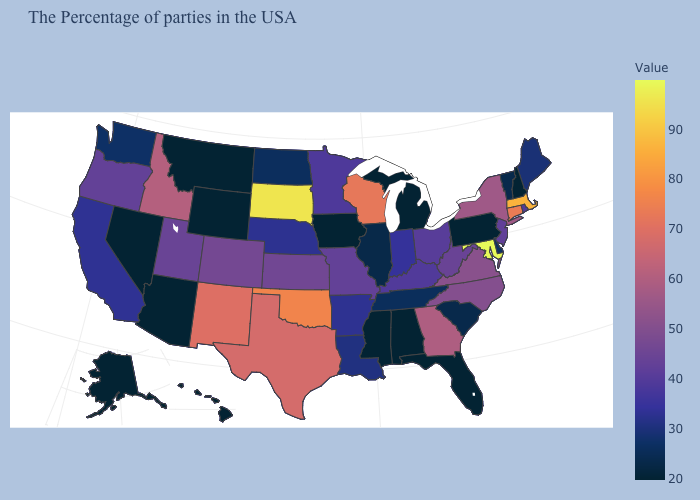Among the states that border Washington , does Oregon have the lowest value?
Concise answer only. Yes. Does South Dakota have the highest value in the MidWest?
Be succinct. Yes. Which states hav the highest value in the West?
Keep it brief. New Mexico. Among the states that border Iowa , does Illinois have the lowest value?
Keep it brief. Yes. 